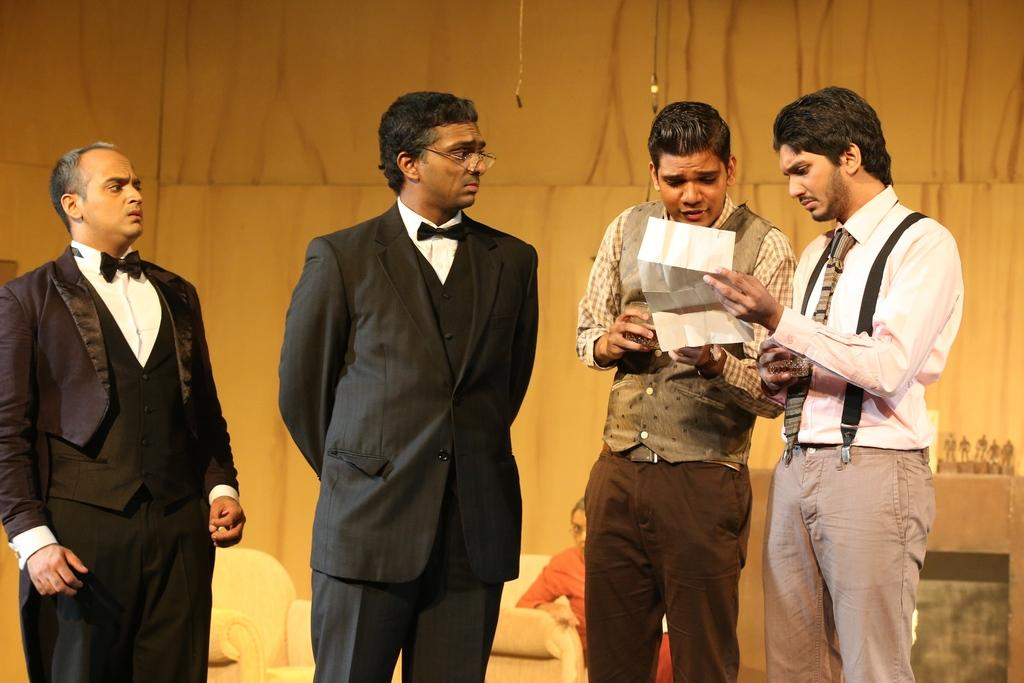How many people are in the image? There are four persons in the image. What are two of the persons doing? Two of the persons are looking at a paper. What can be seen in the background of the image? There are sofas in the background of the image, and there is a person sitting on a sofa. What is visible on one side of the image? There is a wall visible in the image. What type of plant is being used for payment in the image? There is no plant or payment transaction present in the image. Is anyone driving a vehicle in the image? There is no vehicle or driving activity depicted in the image. 